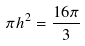Convert formula to latex. <formula><loc_0><loc_0><loc_500><loc_500>\pi h ^ { 2 } = \frac { 1 6 \pi } { 3 }</formula> 